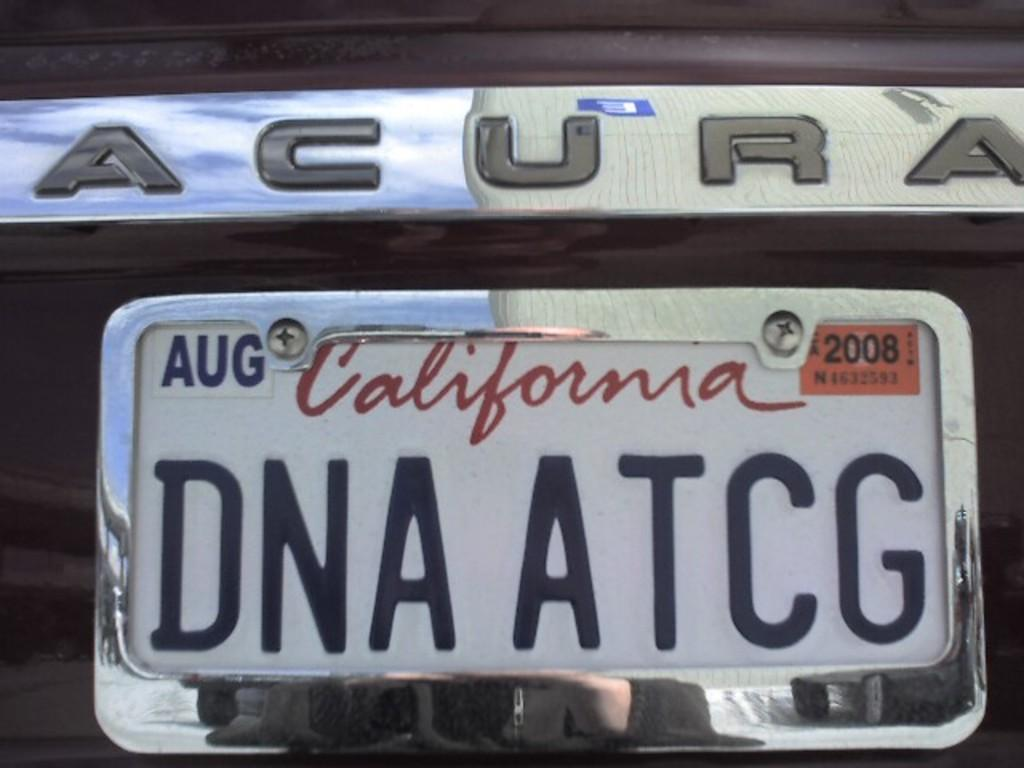<image>
Create a compact narrative representing the image presented. California license plate that says DNA ATCG on it. 